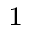Convert formula to latex. <formula><loc_0><loc_0><loc_500><loc_500>^ { 1 }</formula> 